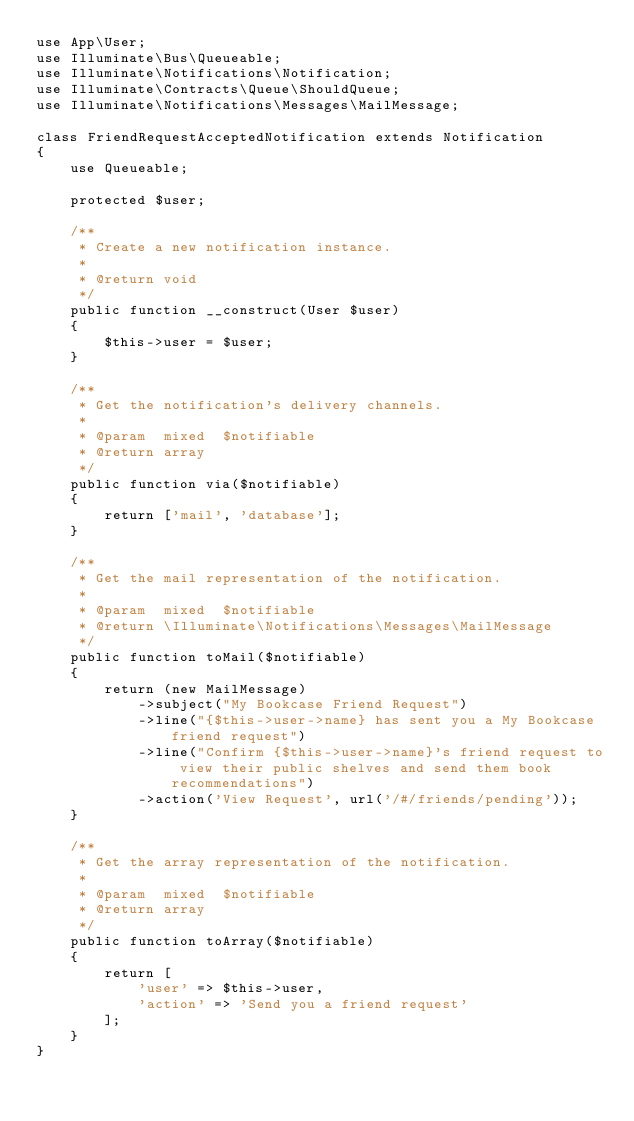Convert code to text. <code><loc_0><loc_0><loc_500><loc_500><_PHP_>use App\User;
use Illuminate\Bus\Queueable;
use Illuminate\Notifications\Notification;
use Illuminate\Contracts\Queue\ShouldQueue;
use Illuminate\Notifications\Messages\MailMessage;

class FriendRequestAcceptedNotification extends Notification
{
    use Queueable;

    protected $user;

    /**
     * Create a new notification instance.
     *
     * @return void
     */
    public function __construct(User $user)
    {
        $this->user = $user;
    }

    /**
     * Get the notification's delivery channels.
     *
     * @param  mixed  $notifiable
     * @return array
     */
    public function via($notifiable)
    {
        return ['mail', 'database'];
    }

    /**
     * Get the mail representation of the notification.
     *
     * @param  mixed  $notifiable
     * @return \Illuminate\Notifications\Messages\MailMessage
     */
    public function toMail($notifiable)
    {
        return (new MailMessage)
            ->subject("My Bookcase Friend Request")
            ->line("{$this->user->name} has sent you a My Bookcase friend request")
            ->line("Confirm {$this->user->name}'s friend request to view their public shelves and send them book recommendations")
            ->action('View Request', url('/#/friends/pending'));
    }

    /**
     * Get the array representation of the notification.
     *
     * @param  mixed  $notifiable
     * @return array
     */
    public function toArray($notifiable)
    {
        return [
            'user' => $this->user,
            'action' => 'Send you a friend request'
        ];
    }
}
</code> 